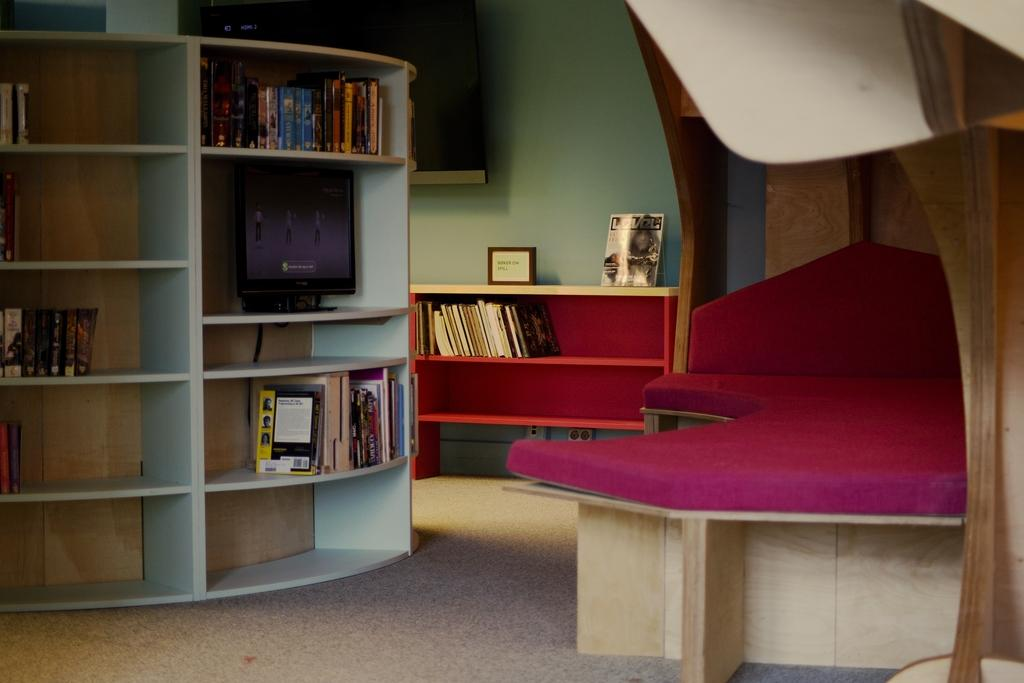What type of furniture is present in the image? There is a bed in the image. What can be seen on the bed? There are books on the bed. What is the primary object visible in the image? There are racks in the image. What type of electronic device is present in the image? There is a screen in the image. What type of structure is visible in the image? There is a wall in the image. What type of decorative item is present in the image? There is a frame in the image. What type of force is being applied to the books on the bed in the image? There is no indication of any force being applied to the books on the bed in the image. What time of day is depicted in the image? The time of day is not discernible from the image. What type of bird is present in the image? There is no bird, including a turkey, present in the image. 